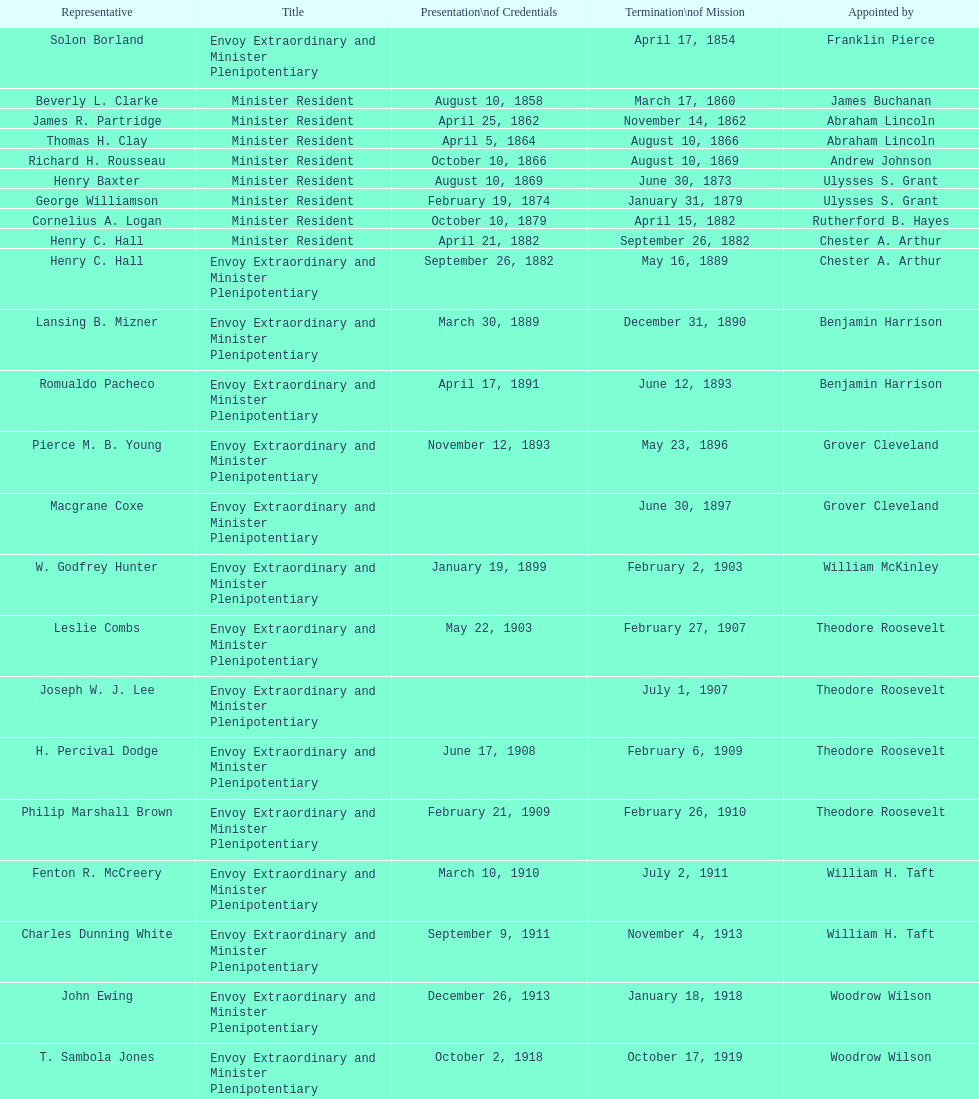Is solon borland a delegate? Yes. 